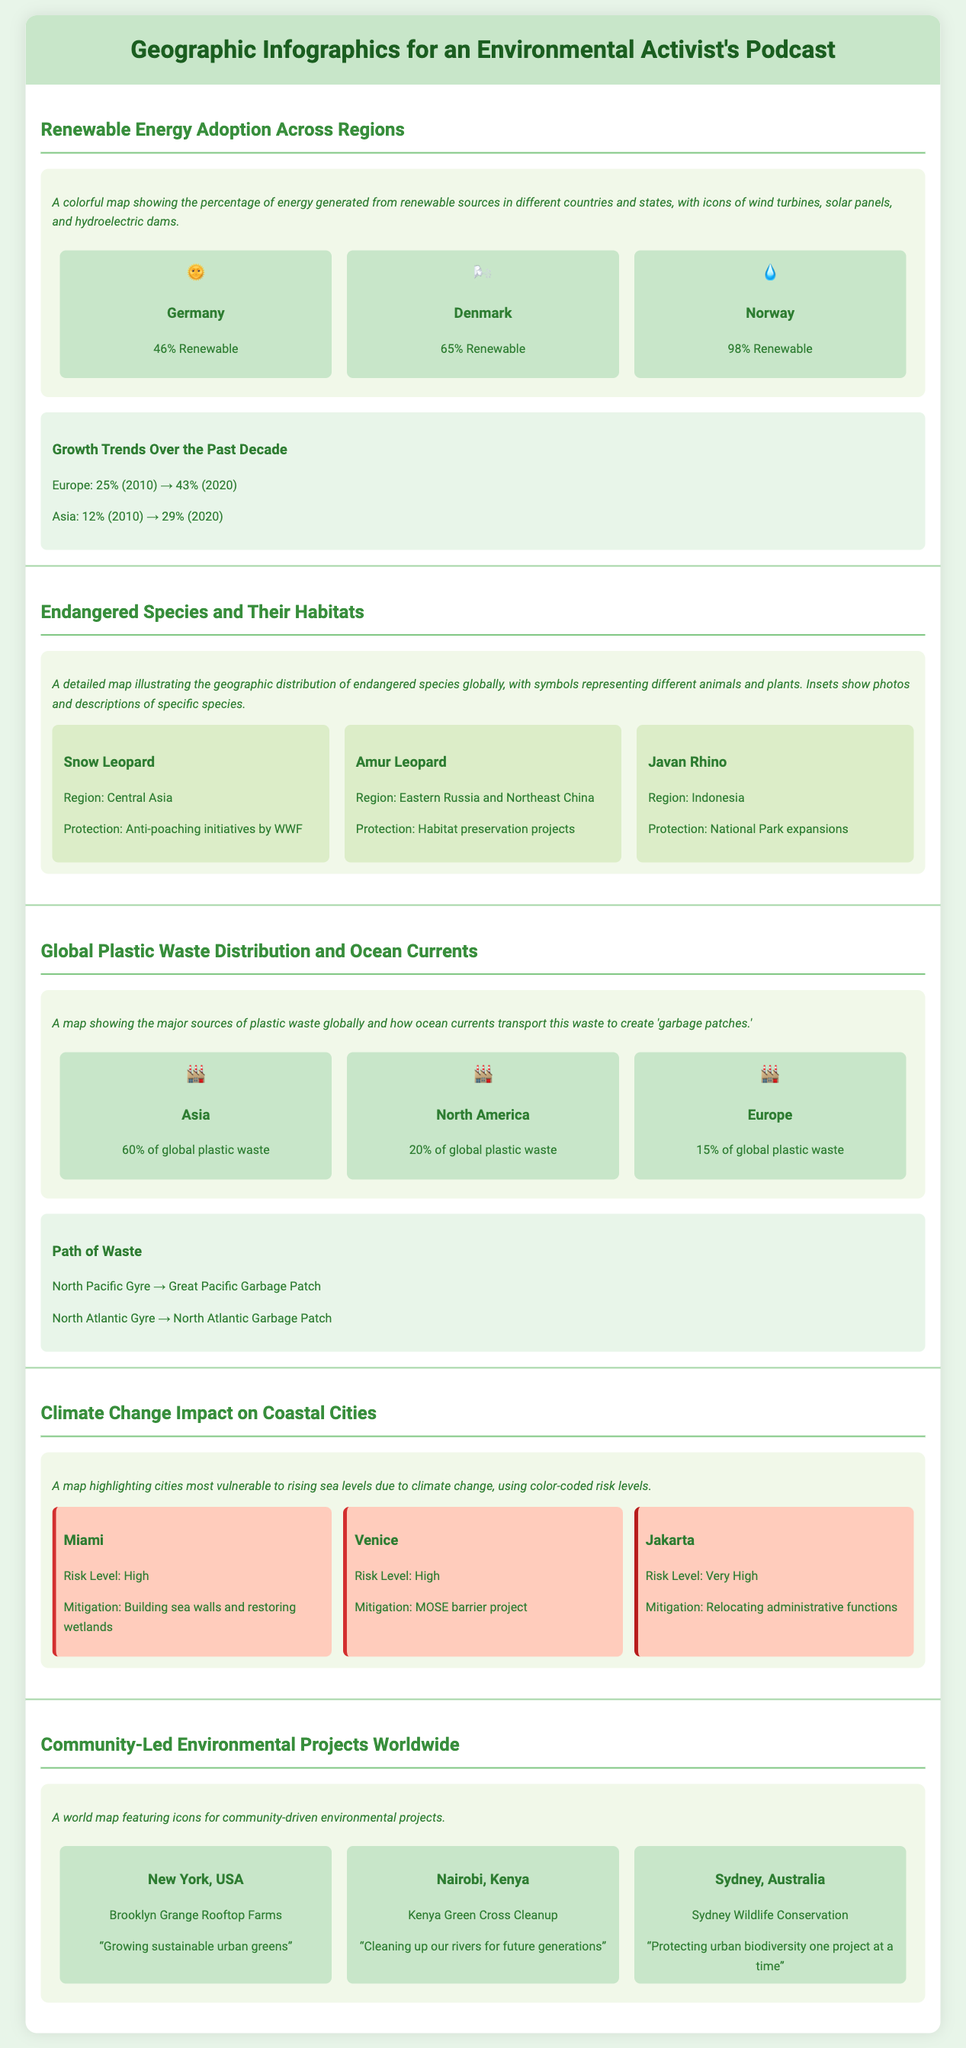What percentage of renewable energy does Norway produce? According to the infographic, Norway generates 98% of its energy from renewable sources.
Answer: 98% Which region's snow leopard is highlighted in the document? The infographic states that the snow leopard is located in Central Asia.
Answer: Central Asia What is the estimated percentage of plastic waste from Asia? The document indicates that Asia accounts for 60% of global plastic waste.
Answer: 60% What risk level is assigned to Jakarta in the climate change section? The infographic categorizes Jakarta as having a very high risk level due to rising sea levels.
Answer: Very High Which community project is located in Nairobi, Kenya? The infographic mentions the Kenya Green Cross Cleanup as a community project in Nairobi.
Answer: Kenya Green Cross Cleanup What growth trend did Europe experience in renewable energy from 2010 to 2020? The document notes that Europe grew from 25% renewable energy in 2010 to 43% in 2020.
Answer: 25% to 43% What is the primary protection measure for the Amur leopard? The infographic mentions that habitat preservation projects are being implemented to protect the Amur leopard.
Answer: Habitat preservation projects Which city's mitigation efforts include building sea walls? Miami is noted in the infographic for its mitigation efforts that include building sea walls.
Answer: Miami How many endangered species descriptions are provided in the document? The infographic includes three descriptions of endangered species: Snow Leopard, Amur Leopard, and Javan Rhino.
Answer: Three 